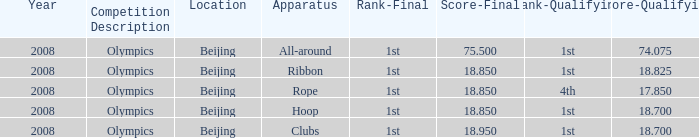075? 75.5. 